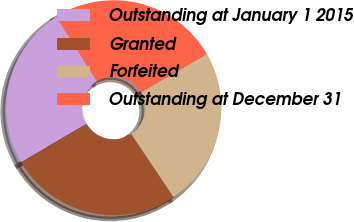<chart> <loc_0><loc_0><loc_500><loc_500><pie_chart><fcel>Outstanding at January 1 2015<fcel>Granted<fcel>Forfeited<fcel>Outstanding at December 31<nl><fcel>24.5%<fcel>25.92%<fcel>23.97%<fcel>25.61%<nl></chart> 